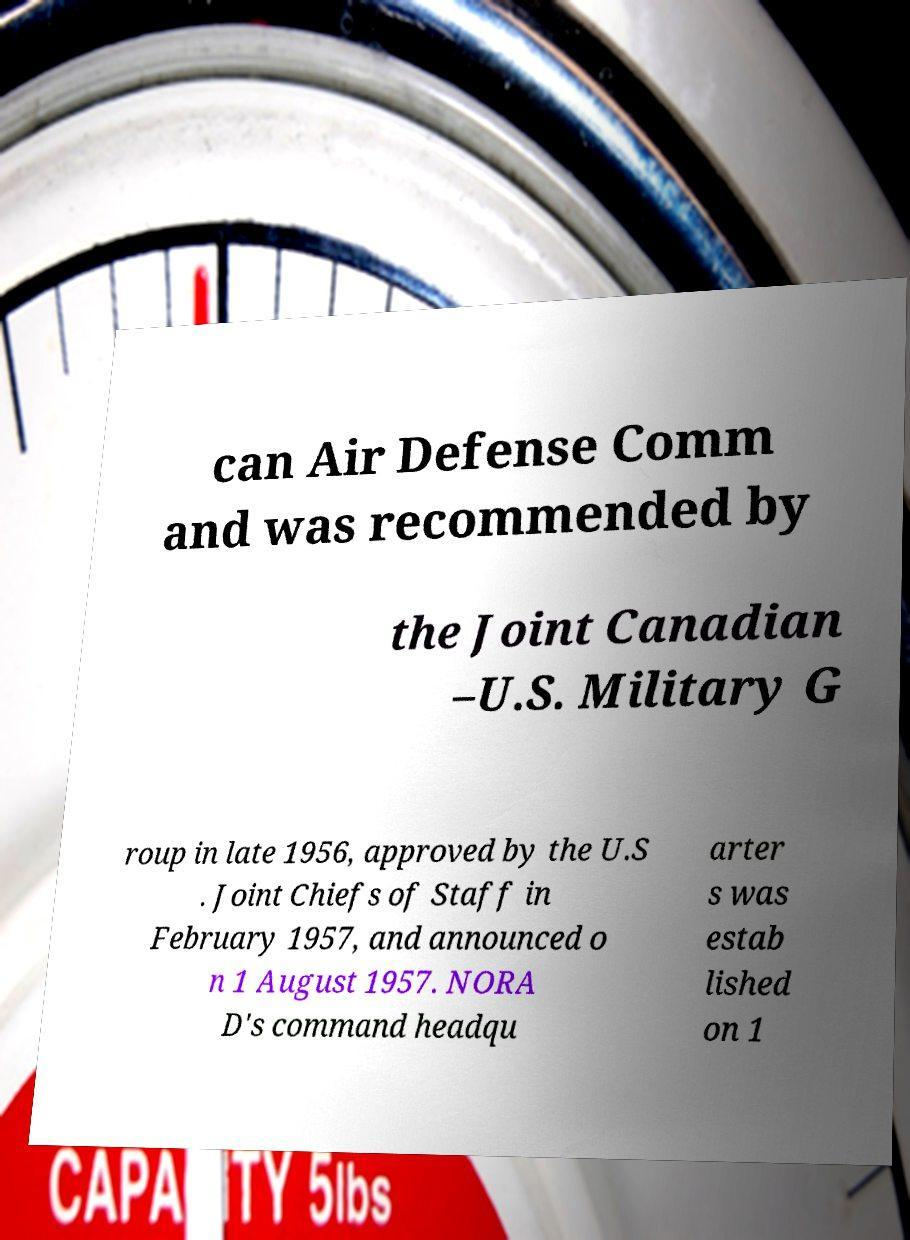Could you extract and type out the text from this image? can Air Defense Comm and was recommended by the Joint Canadian –U.S. Military G roup in late 1956, approved by the U.S . Joint Chiefs of Staff in February 1957, and announced o n 1 August 1957. NORA D's command headqu arter s was estab lished on 1 